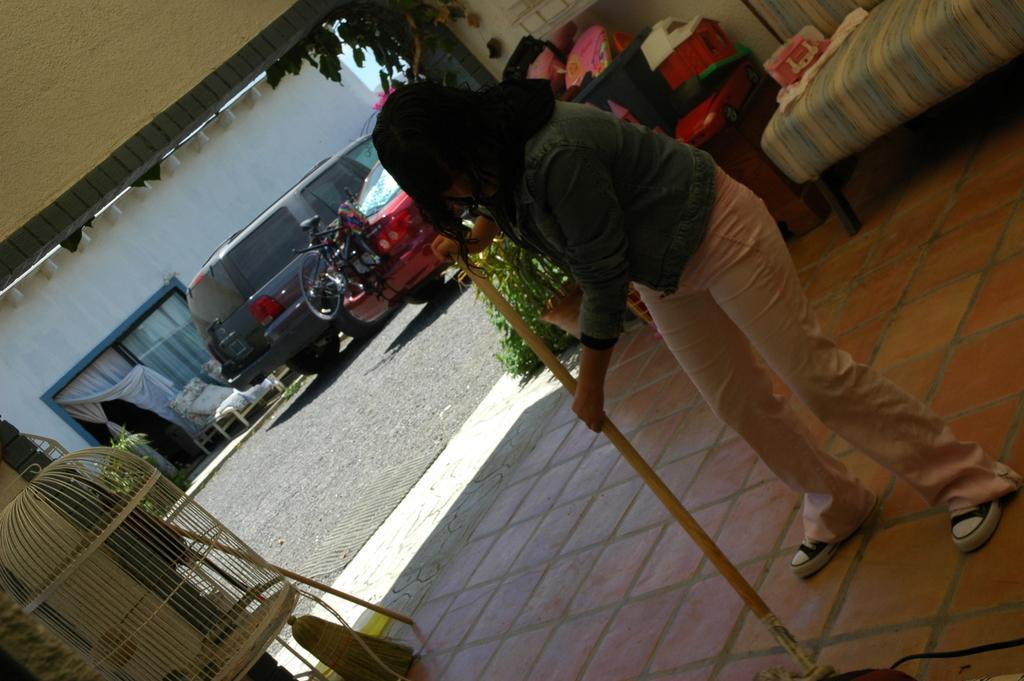How would you summarize this image in a sentence or two? On the left side of the image we can see a door, curtain, chairs and road. In the middle of the image we can see cars, a bicycle and a lady where is she holding something in her hands. On the right side of the image we can see a bed on which some objects are there. 